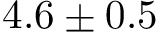<formula> <loc_0><loc_0><loc_500><loc_500>4 . 6 \pm 0 . 5</formula> 